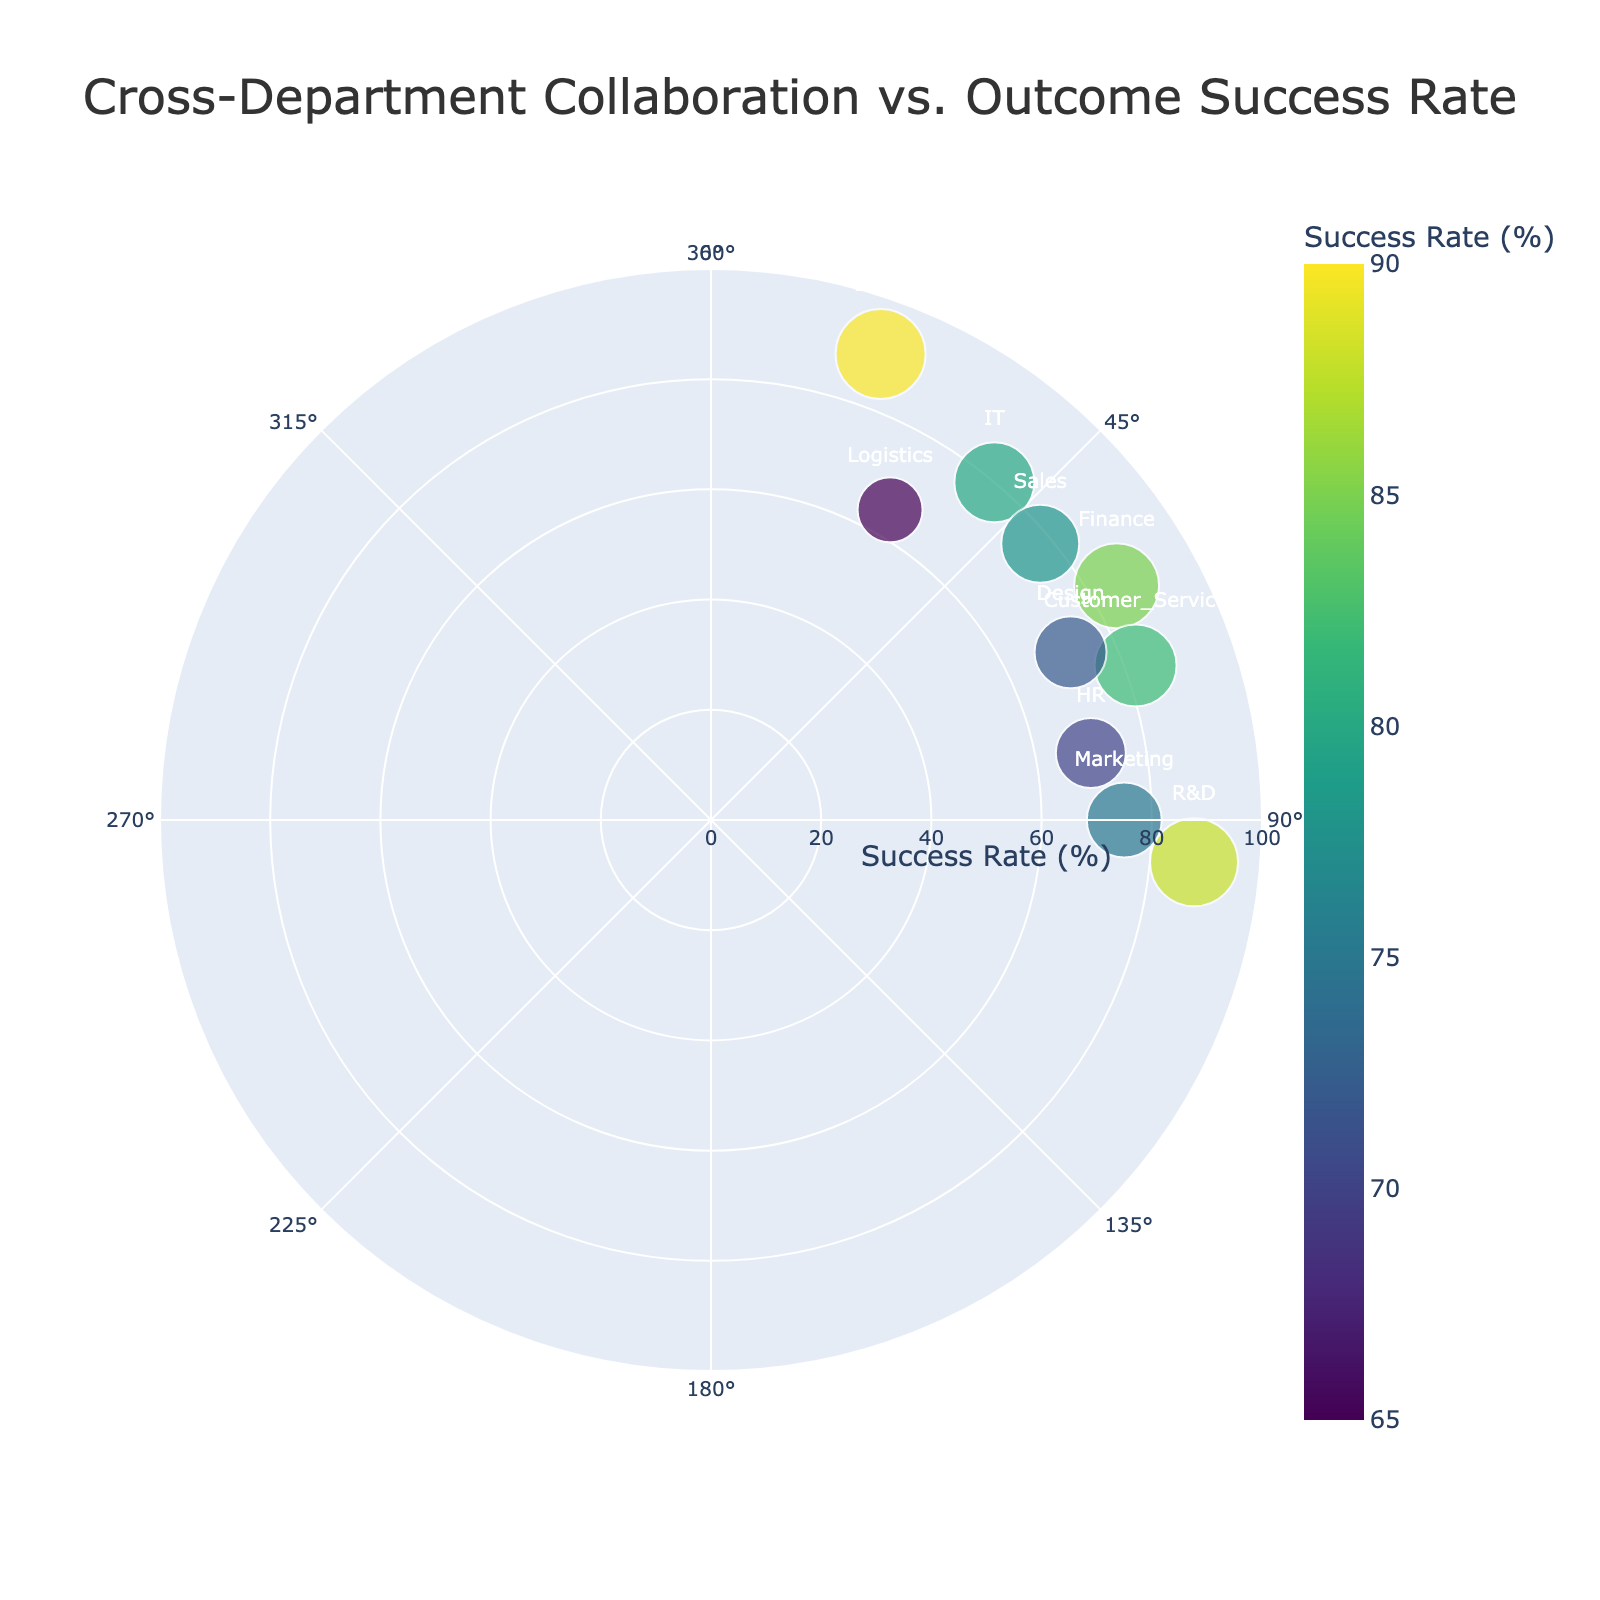which department has the highest Outcome Success Rate? To find the department with the highest Outcome Success Rate, examine the radial axis (representing the success rate) and identify the data point that is farthest from the center. The department furthest out is Legal with a 90% success rate.
Answer: Legal what is the title of the polar scatter chart? The title of the polar scatter chart is displayed at the top of the figure. It reads, "Cross-Department Collaboration vs. Outcome Success Rate."
Answer: Cross-Department Collaboration vs. Outcome Success Rate how many departments have a Collaboration Degree between 60° and 90°? To determine how many departments have a Collaboration Degree between 60° and 90°, observe the angular axis (representing the Collaboration Degree) and count the markers that fall within this range. Departments falling in this range include Marketing, Finance, Consumer Service, HR, and Design.
Answer: 5 which department has the lowest Collaboration Degree? To find the department with the lowest Collaboration Degree, look at the angular axis and identify the data point positioned closest to the 0° direction. The department closest to this direction is Legal, with a Collaboration Degree of 20°.
Answer: Legal what is the average Outcome Success Rate of the departments with Collaboration Degrees over 75°? Departments with Collaboration Degrees over 75° are Marketing, HR, and R&D. Their Outcome Success Rates are 75, 70, and 88, respectively. The average is calculated as (75 + 70 + 88) / 3.
Answer: 77.67 are there more departments with Collaboration Degrees above or below 50°? To determine this, count the number of departments above 50° and below 50°. Above 50° include Marketing, Finance, HR, Customer Service, R&D, and Design. Below 50° include IT, Sales, Logistics, and Legal.
Answer: Above 50° which department has the largest marker size on the plot? The marker size is proportional to the Outcome Success Rate. By looking at the plot, the largest marker belongs to the Legal department, which has an Outcome Success Rate of 90%.
Answer: Legal which project has a Collaboration Degree closest to the average Collaboration Degree of all projects? Calculate the average Collaboration Degree of all projects. Summing up the Collaboration Degrees (90+60+40+80+50+70+95+30+20+65) gives 600, and dividing by 10 departments, the average is 60°. The project close to this average is Customer Service's CRM Integration with 70°.
Answer: CRM Integration how is the Outcome Success Rate distributed among departments with high Collaboration Degrees (above 70°)? High Collaboration Degrees departments are Marketing, HR, Customer Service, and R&D with Outcome Success Rates of 75, 70, 82, and 88. These values show above average Outcome Success Rates.
Answer: Above average what does the color of the markers indicate? The color of the markers represents the Outcome Success Rate, with the intensity of the color changing according to a predefined color scale. Darker shades represent higher success rates.
Answer: Outcome Success Rate 